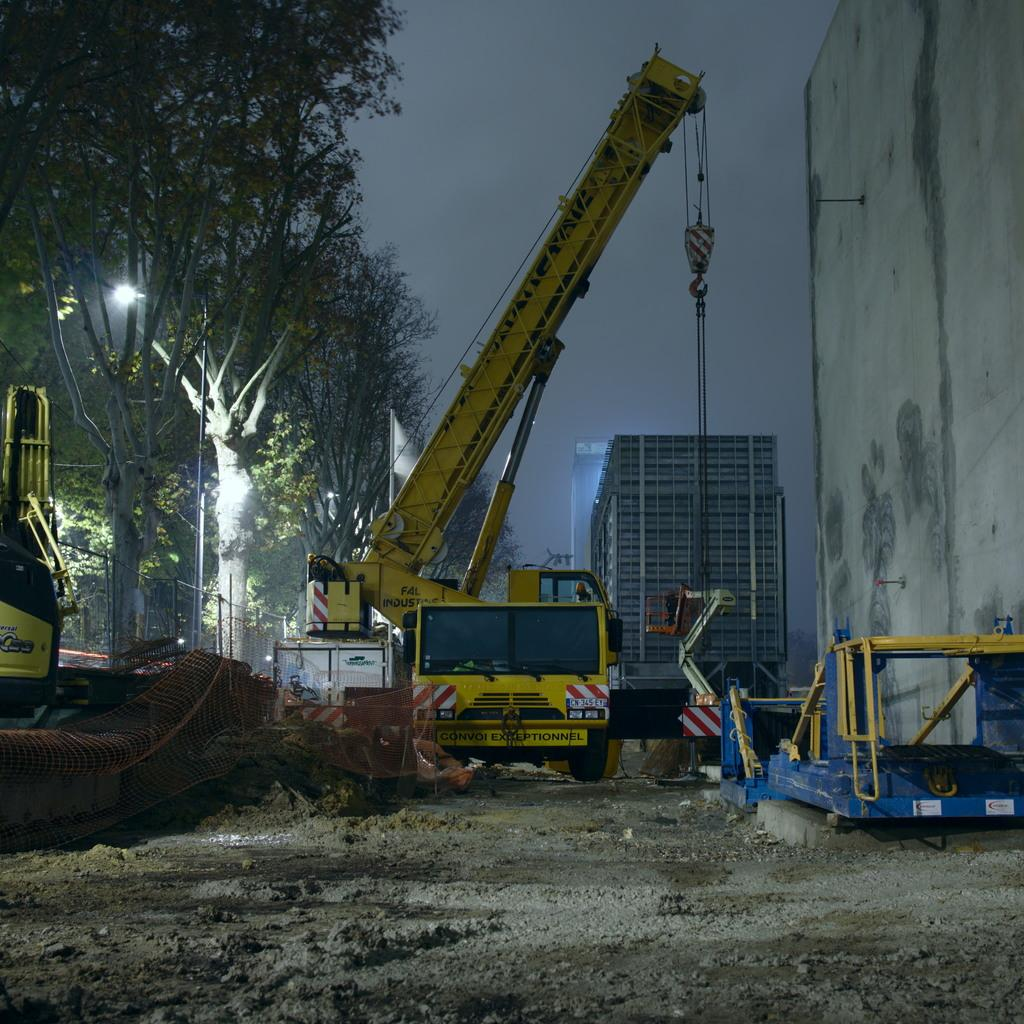What type of vegetation can be seen in the image? There are trees in the image. What type of vehicle is present in the image? There is a truck in the image. What type of structures can be seen in the image? There are buildings in the image. What else can be seen in the image besides trees, truck, and buildings? Other objects are present in the image. What is visible in the background of the image? The sky is visible in the background of the image. What type of crime is being committed in the image? There is no indication of any crime being committed in the image. What sound does the bat make in the image? There is no bat present in the image. 